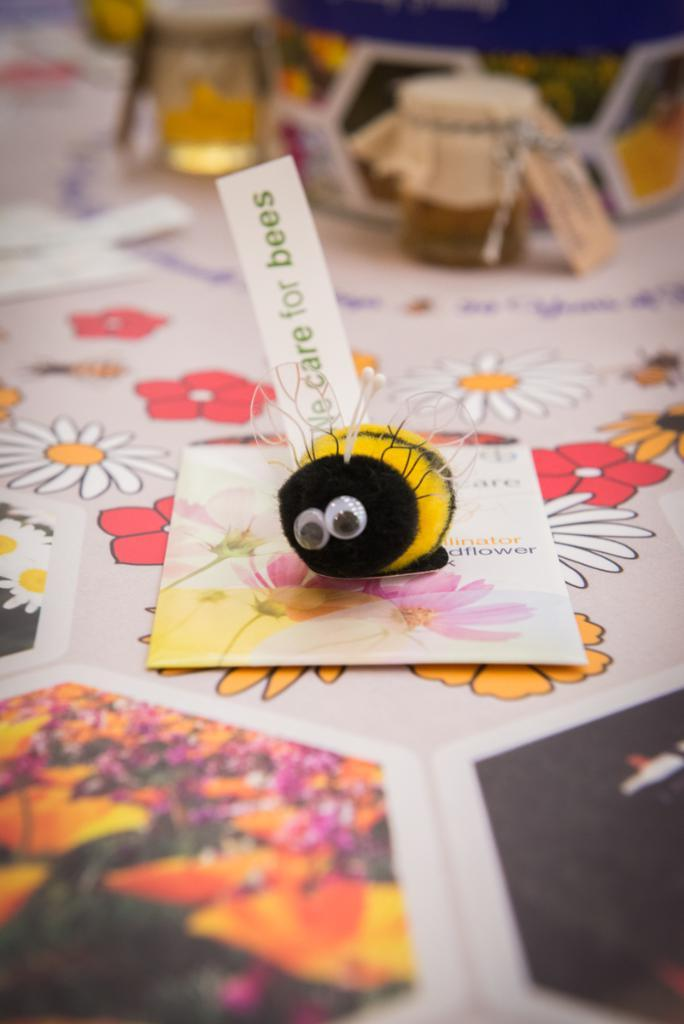<image>
Share a concise interpretation of the image provided. the word bees is on the card behind the bee 